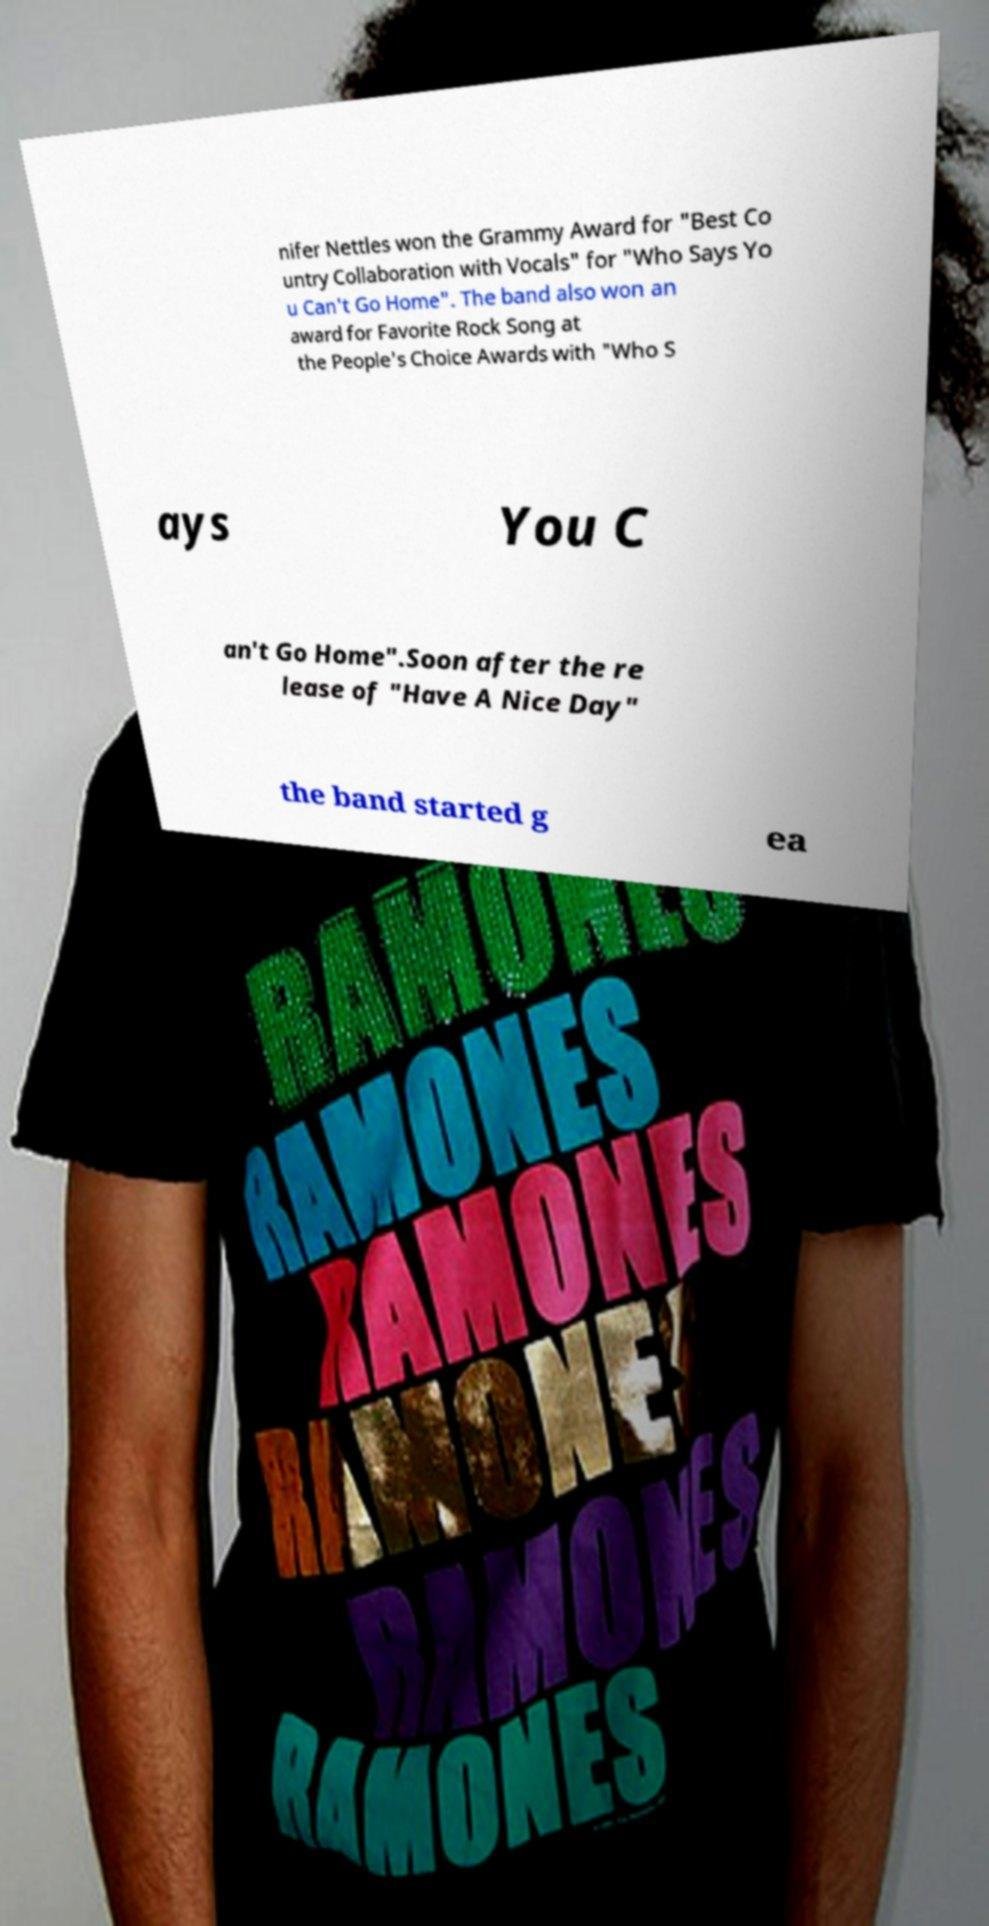Please read and relay the text visible in this image. What does it say? nifer Nettles won the Grammy Award for "Best Co untry Collaboration with Vocals" for "Who Says Yo u Can't Go Home". The band also won an award for Favorite Rock Song at the People's Choice Awards with "Who S ays You C an't Go Home".Soon after the re lease of "Have A Nice Day" the band started g ea 